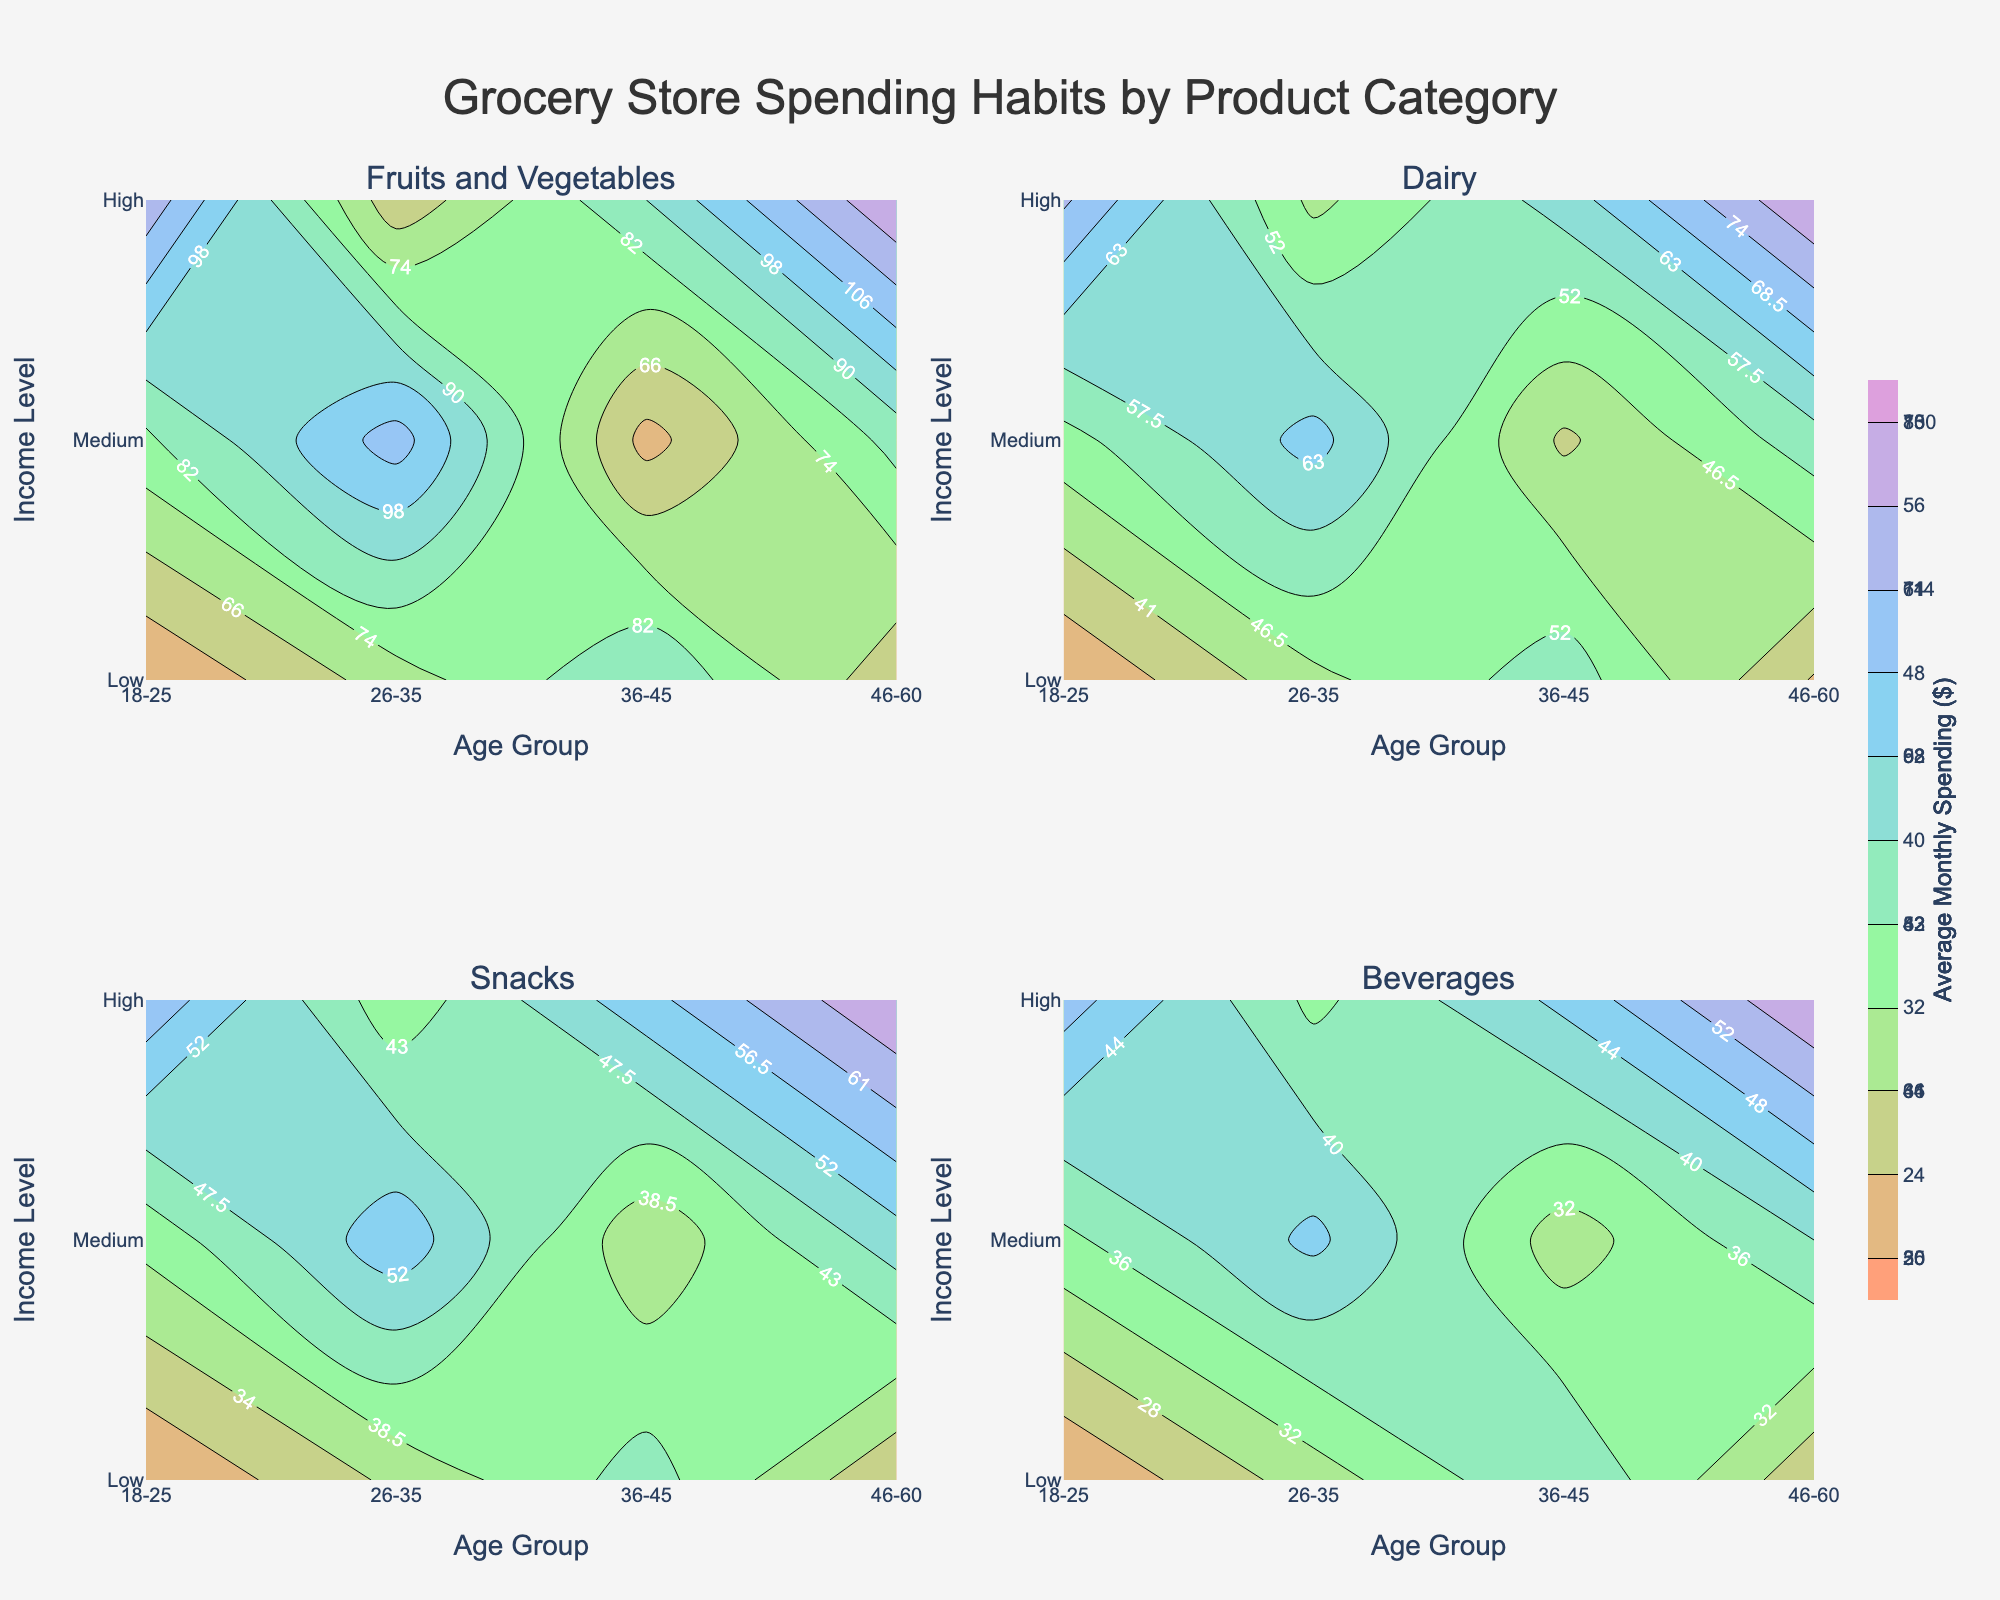What is the title of the figure? The title is displayed prominently at the top of the figure. The text says "Grocery Store Spending Habits by Product Category".
Answer: Grocery Store Spending Habits by Product Category Which product category has the highest average monthly spending for the age group 46-60 with a high-income level? Looking at the color gradients in each subplot category for 46-60 age group and high income, the brightest (or highest value) region is observed in the Fruits and Vegetables subplot.
Answer: Fruits and Vegetables What is the color scale used in the figure? The figure uses a range of colors starting with shades of light salmon, light green, sky blue, and lavender.
Answer: Light salmon, light green, sky blue, lavender In which product category do low-income 18-25-year-olds spend more compared to low-income 26-35-year-olds? By comparing the contours for the 18-25 and 26-35 low-income levels across all subplots, we see that for the "Fruits and Vegetables" category, low-income 18-25-year-olds spend more ($50) compared to 26-35-year-olds ($60). For Snacks, low-income 18-25-year-olds spend less ($25) compared to 26-35-year-olds ($30).
Answer: Fruits and Vegetables Which age group shows the steepest increase in spending as income level rises in the Dairy product category? Looking at the Dairy subplot, the steepest rise in spending occurs for the 46-60 age group, where the contour lines are most closely packed as income rises from low to high.
Answer: 46-60 Among all categories, what is the highest average monthly spending value observed and in which category and group is it found? Observing the subplots, the highest spending value is $130 for the Fruits and Vegetables category, for the age group 46-60 with high income.
Answer: $130 in Fruits and Vegetables for 46-60 age group with high income How does the spending on beverages for medium-income levels compare across different age groups? In the Beverages subplot, the spending for medium-income levels starts at $30 for 18-25, $35 for 26-35, $40 for 36-45, and $45 for 46-60. It consistently increases with age.
Answer: Increases with age What is the average monthly spending on snacks for the 36-45 age group with a low-income level? In the Snacks subplot, for the age group 36-45 with low income, the contour indicates the average monthly spending as $35.
Answer: $35 